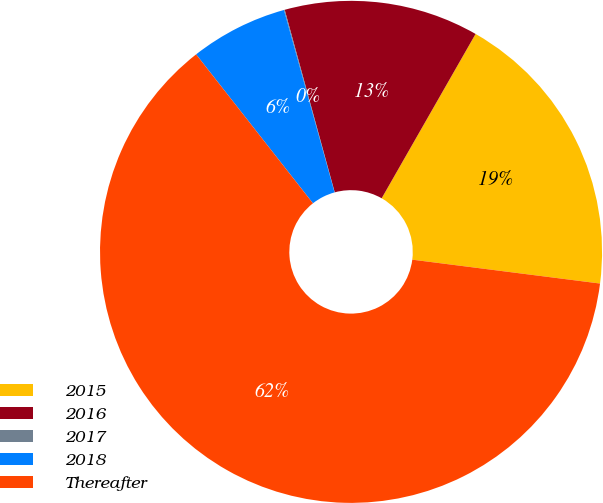Convert chart to OTSL. <chart><loc_0><loc_0><loc_500><loc_500><pie_chart><fcel>2015<fcel>2016<fcel>2017<fcel>2018<fcel>Thereafter<nl><fcel>18.75%<fcel>12.52%<fcel>0.05%<fcel>6.28%<fcel>62.4%<nl></chart> 